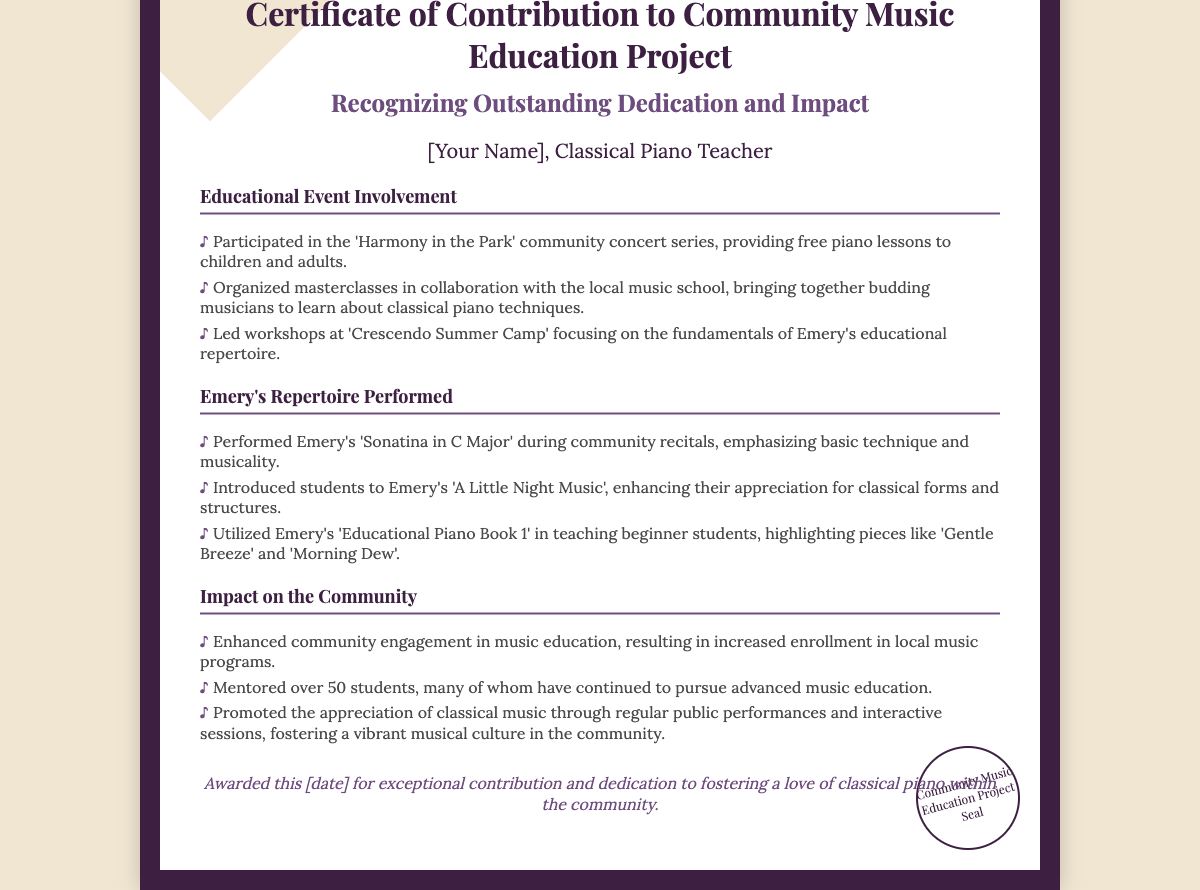What is the title of the certificate? The title is displayed prominently at the top of the certificate.
Answer: Certificate of Contribution to Community Music Education Project Who is the recipient of the certificate? The recipient's name is mentioned under the title as a classical piano teacher.
Answer: [Your Name] What event involved free piano lessons? This event is identified in the list of educational event involvement.
Answer: Harmony in the Park Which repertoire piece was performed during community recitals? This is noted in the section about Emery's repertoire performed.
Answer: Sonatina in C Major How many students were mentored according to the impact section? The number of mentored students is stated in the impact list.
Answer: Over 50 students What was a focus of the workshops at 'Crescendo Summer Camp'? The focus is outlined in the description of the workshops offered.
Answer: Fundamentals of Emery's educational repertoire What is the date on which the certificate was awarded? The date will be placed in the footer of the document to signify the award.
Answer: [date] What seal is noted at the bottom of the certificate? The seal indicates the organization involved in the project.
Answer: Community Music Education Project Seal 